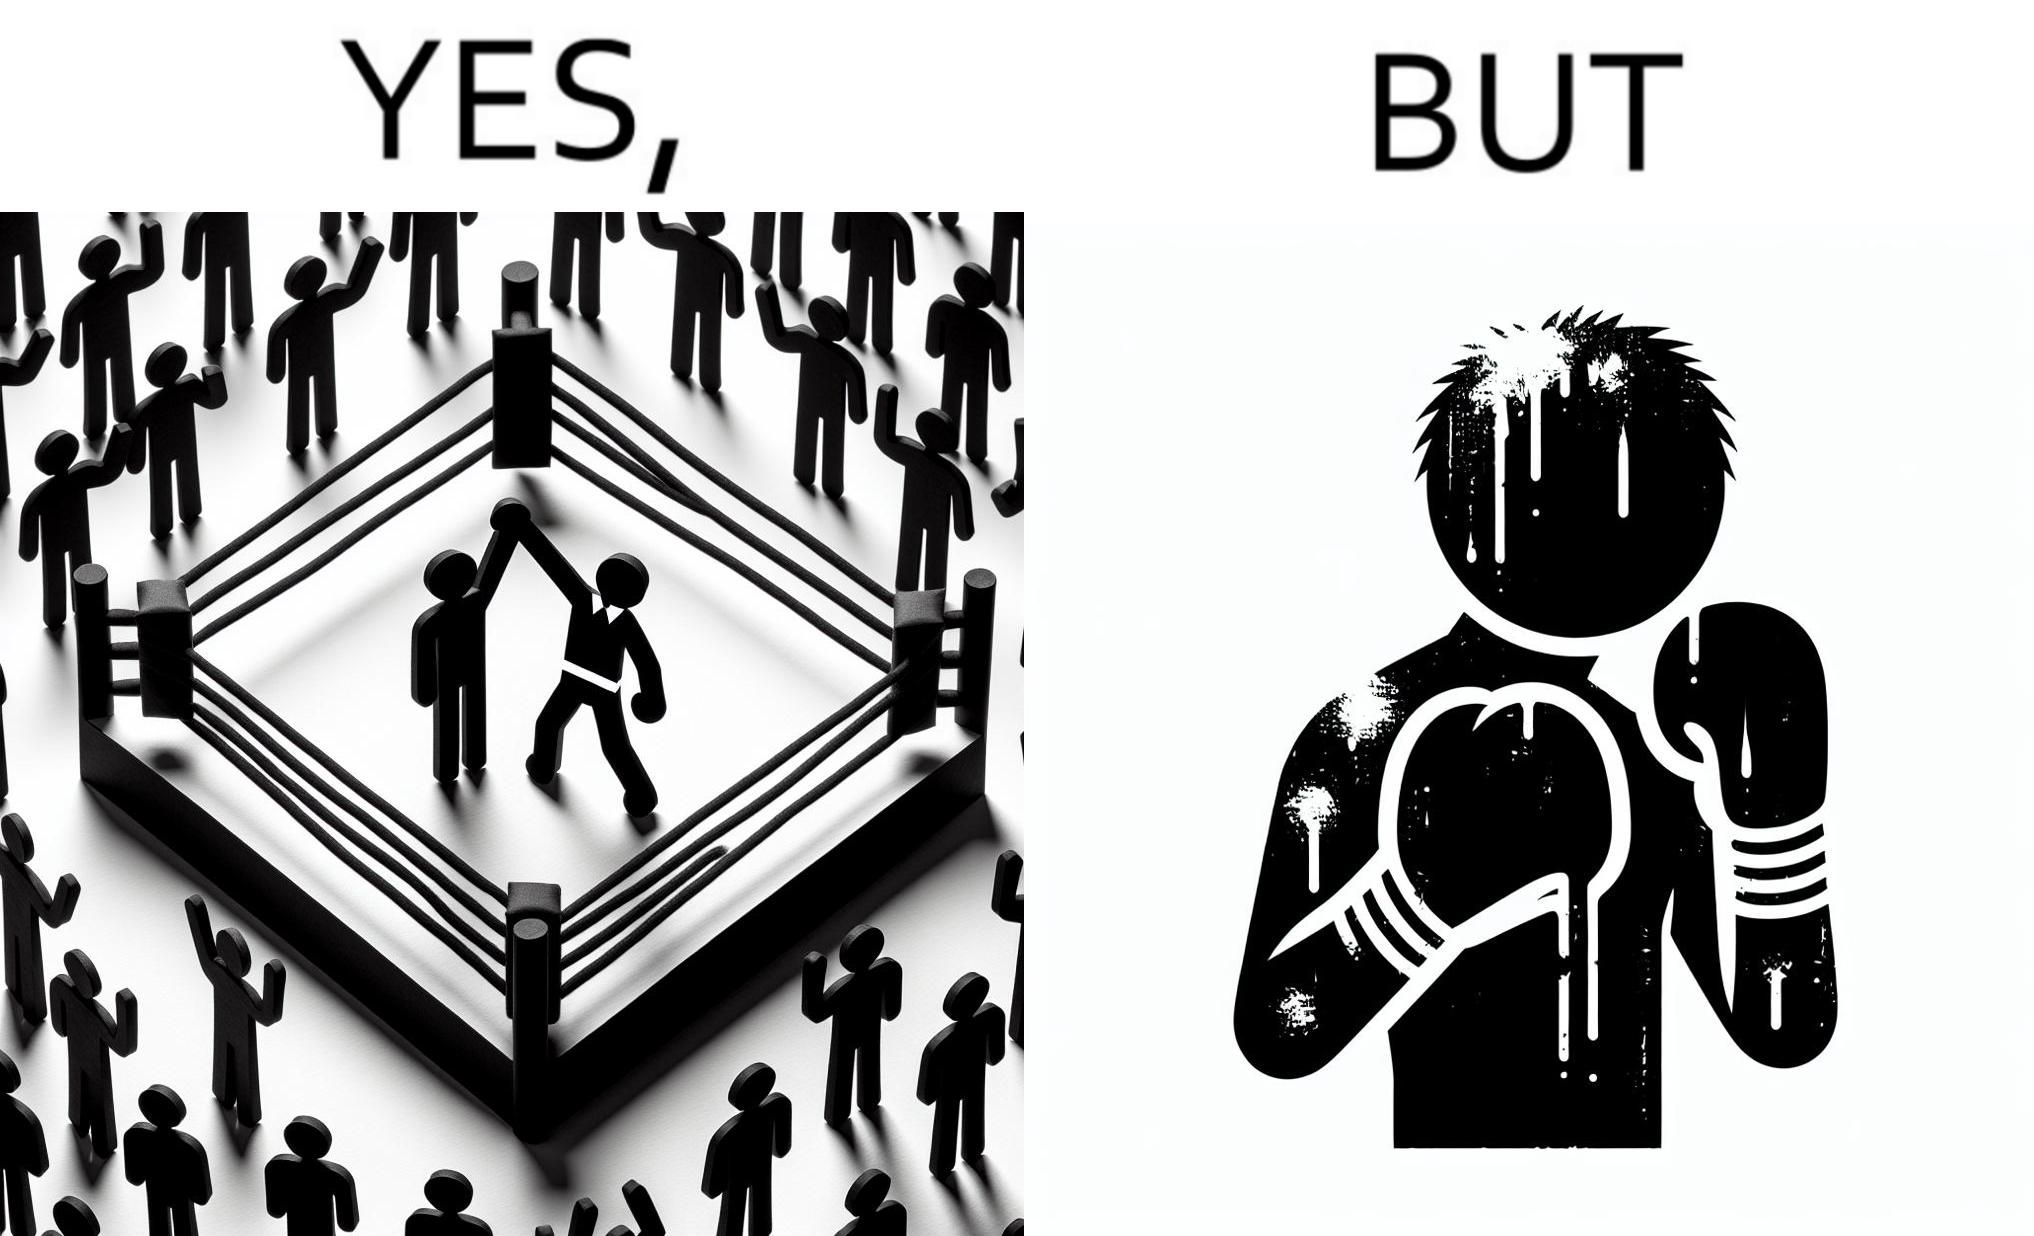Provide a description of this image. The image is ironic because even though a boxer has won the match and it is supposed to be a moment of celebration, the boxer got bruised in several places during the match. This is an illustration of what hurdles a person has to go through in order to succeed. 